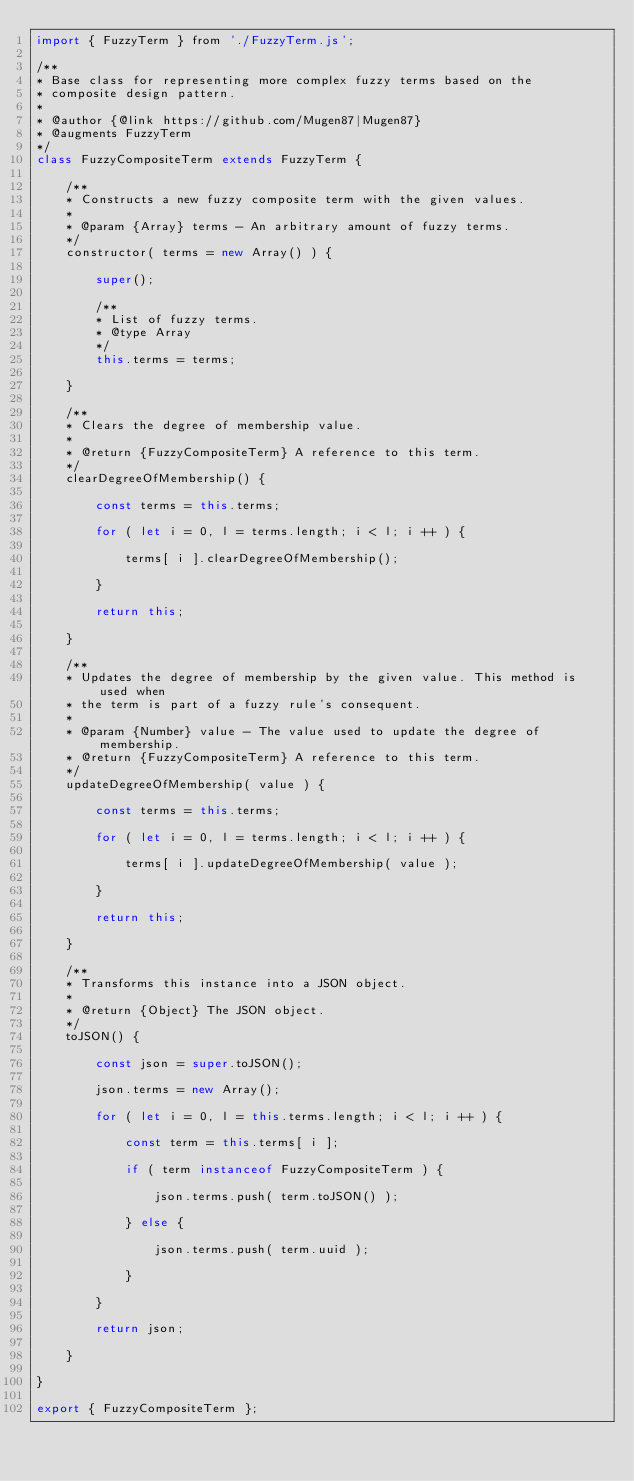Convert code to text. <code><loc_0><loc_0><loc_500><loc_500><_JavaScript_>import { FuzzyTerm } from './FuzzyTerm.js';

/**
* Base class for representing more complex fuzzy terms based on the
* composite design pattern.
*
* @author {@link https://github.com/Mugen87|Mugen87}
* @augments FuzzyTerm
*/
class FuzzyCompositeTerm extends FuzzyTerm {

	/**
	* Constructs a new fuzzy composite term with the given values.
	*
	* @param {Array} terms - An arbitrary amount of fuzzy terms.
	*/
	constructor( terms = new Array() ) {

		super();

		/**
		* List of fuzzy terms.
		* @type Array
		*/
		this.terms = terms;

	}

	/**
	* Clears the degree of membership value.
	*
	* @return {FuzzyCompositeTerm} A reference to this term.
	*/
	clearDegreeOfMembership() {

		const terms = this.terms;

		for ( let i = 0, l = terms.length; i < l; i ++ ) {

			terms[ i ].clearDegreeOfMembership();

		}

		return this;

	}

	/**
	* Updates the degree of membership by the given value. This method is used when
	* the term is part of a fuzzy rule's consequent.
	*
	* @param {Number} value - The value used to update the degree of membership.
	* @return {FuzzyCompositeTerm} A reference to this term.
	*/
	updateDegreeOfMembership( value ) {

		const terms = this.terms;

		for ( let i = 0, l = terms.length; i < l; i ++ ) {

			terms[ i ].updateDegreeOfMembership( value );

		}

		return this;

	}

	/**
	* Transforms this instance into a JSON object.
	*
	* @return {Object} The JSON object.
	*/
	toJSON() {

		const json = super.toJSON();

		json.terms = new Array();

		for ( let i = 0, l = this.terms.length; i < l; i ++ ) {

			const term = this.terms[ i ];

			if ( term instanceof FuzzyCompositeTerm ) {

				json.terms.push( term.toJSON() );

			} else {

				json.terms.push( term.uuid );

			}

		}

		return json;

	}

}

export { FuzzyCompositeTerm };
</code> 